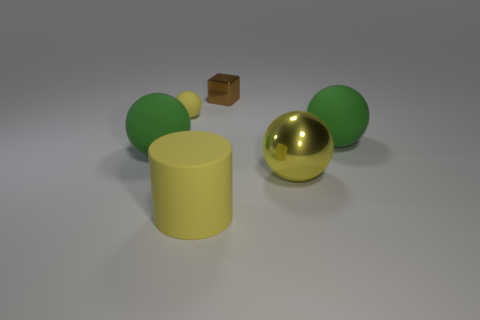Add 4 small gray metallic balls. How many objects exist? 10 Subtract all cylinders. How many objects are left? 5 Subtract all small matte things. Subtract all small shiny cubes. How many objects are left? 4 Add 1 large yellow spheres. How many large yellow spheres are left? 2 Add 5 small metal things. How many small metal things exist? 6 Subtract 1 yellow cylinders. How many objects are left? 5 